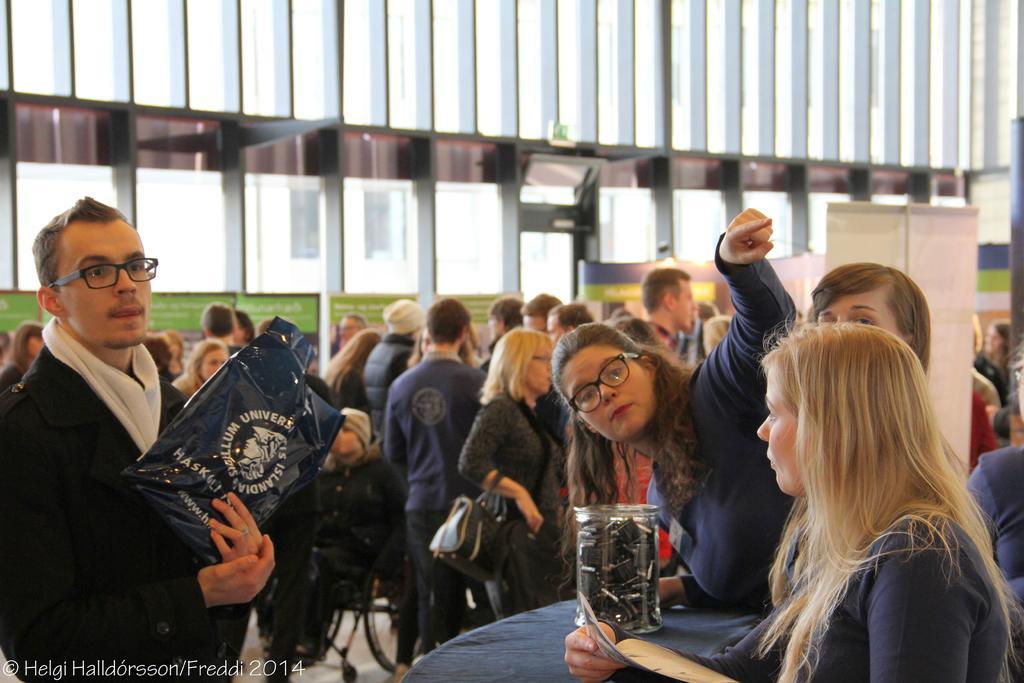Can you describe this image briefly? In this image there are a group of people some of them are walking and some of them are sitting, and in the center there is one person who is sitting on a wheelchair. On the top of the image there is one building and grass. 